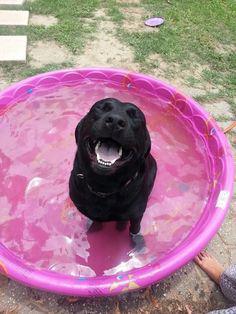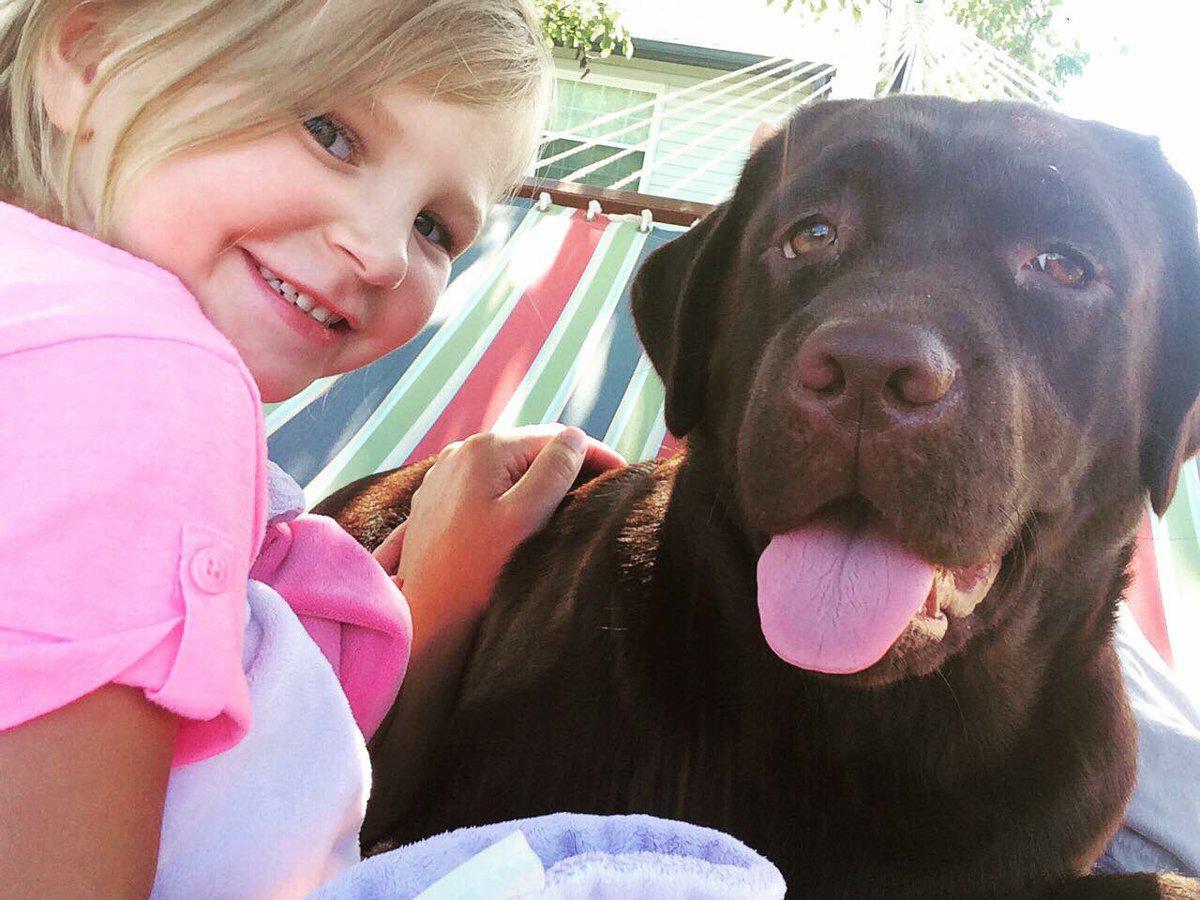The first image is the image on the left, the second image is the image on the right. Considering the images on both sides, is "There is one human and one dog in the right image." valid? Answer yes or no. Yes. The first image is the image on the left, the second image is the image on the right. Evaluate the accuracy of this statement regarding the images: "a human is posing with a brown lab". Is it true? Answer yes or no. Yes. 